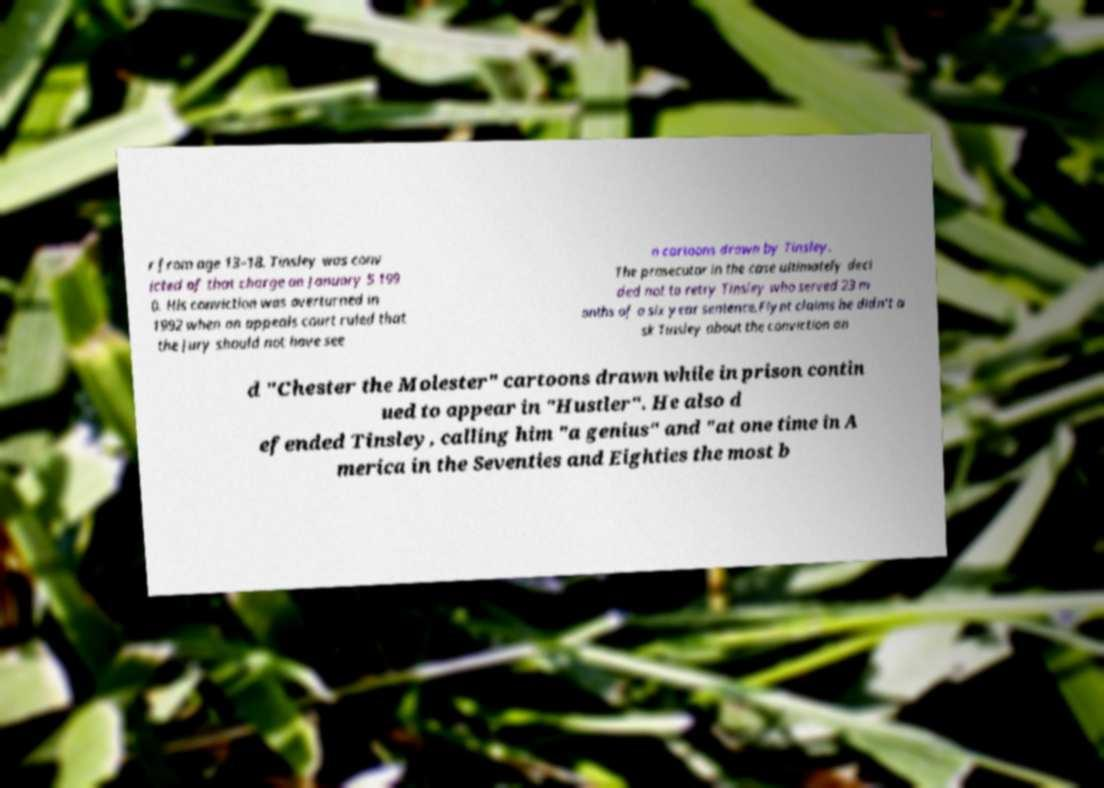Could you assist in decoding the text presented in this image and type it out clearly? r from age 13–18. Tinsley was conv icted of that charge on January 5 199 0. His conviction was overturned in 1992 when an appeals court ruled that the jury should not have see n cartoons drawn by Tinsley. The prosecutor in the case ultimately deci ded not to retry Tinsley who served 23 m onths of a six year sentence.Flynt claims he didn't a sk Tinsley about the conviction an d "Chester the Molester" cartoons drawn while in prison contin ued to appear in "Hustler". He also d efended Tinsley, calling him "a genius" and "at one time in A merica in the Seventies and Eighties the most b 